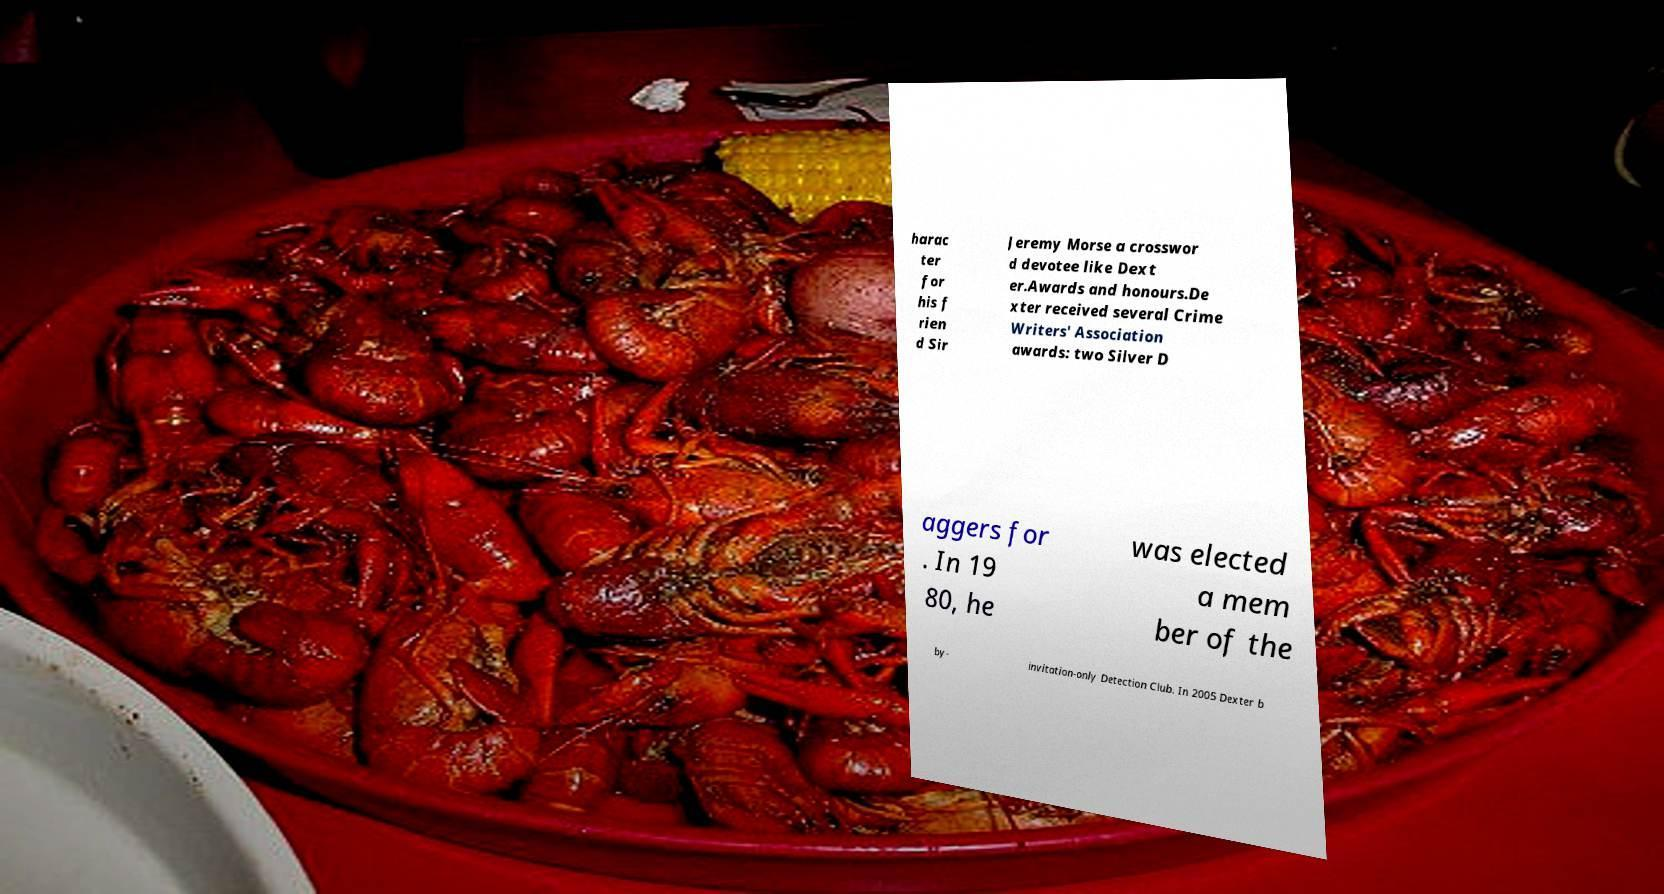Can you accurately transcribe the text from the provided image for me? harac ter for his f rien d Sir Jeremy Morse a crosswor d devotee like Dext er.Awards and honours.De xter received several Crime Writers' Association awards: two Silver D aggers for . In 19 80, he was elected a mem ber of the by- invitation-only Detection Club. In 2005 Dexter b 